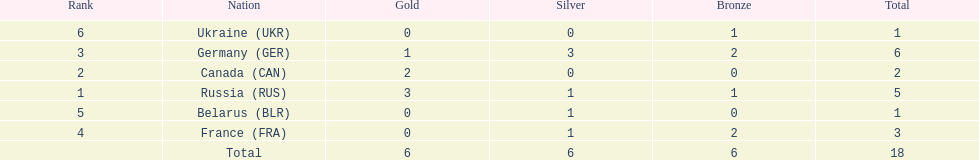Which country won more total medals than tue french, but less than the germans in the 1994 winter olympic biathlon? Russia. 